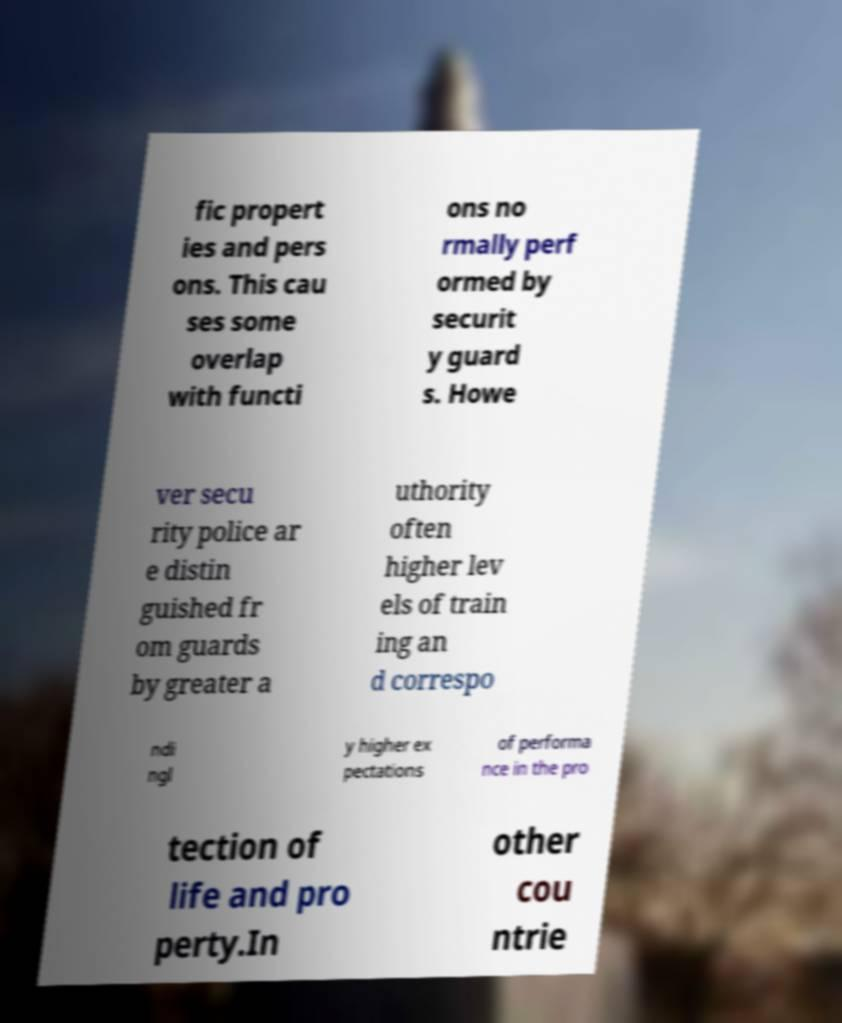Could you assist in decoding the text presented in this image and type it out clearly? fic propert ies and pers ons. This cau ses some overlap with functi ons no rmally perf ormed by securit y guard s. Howe ver secu rity police ar e distin guished fr om guards by greater a uthority often higher lev els of train ing an d correspo ndi ngl y higher ex pectations of performa nce in the pro tection of life and pro perty.In other cou ntrie 